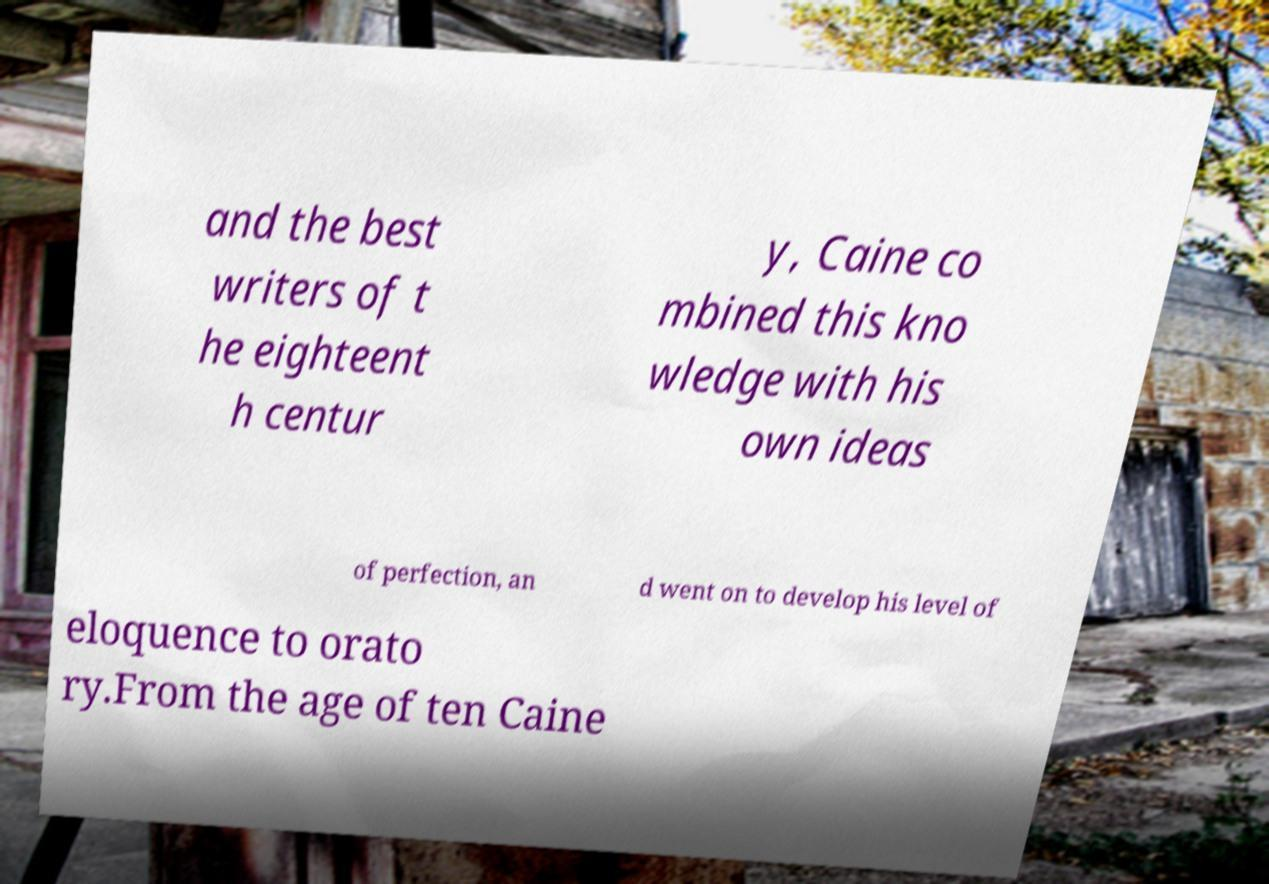Can you read and provide the text displayed in the image?This photo seems to have some interesting text. Can you extract and type it out for me? and the best writers of t he eighteent h centur y, Caine co mbined this kno wledge with his own ideas of perfection, an d went on to develop his level of eloquence to orato ry.From the age of ten Caine 